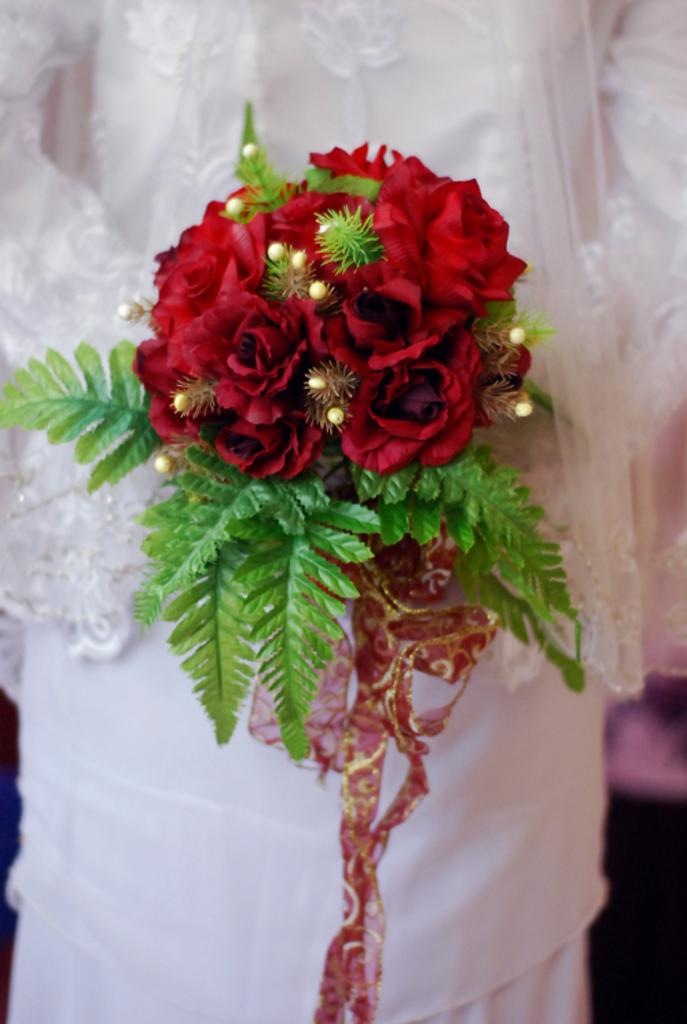What is the main subject of the image? There is a flower bouquet in the image. What color are the flowers in the bouquet? The bouquet contains red flowers. What else is included in the bouquet besides flowers? The bouquet contains leaves and other unspecified items. Who is holding the bouquet in the image? A person wearing a white dress is holding the bouquet. What type of magic spell is being cast on the person holding the bouquet in the image? There is no indication of magic or a spell being cast in the image; it simply shows a person holding a flower bouquet. 